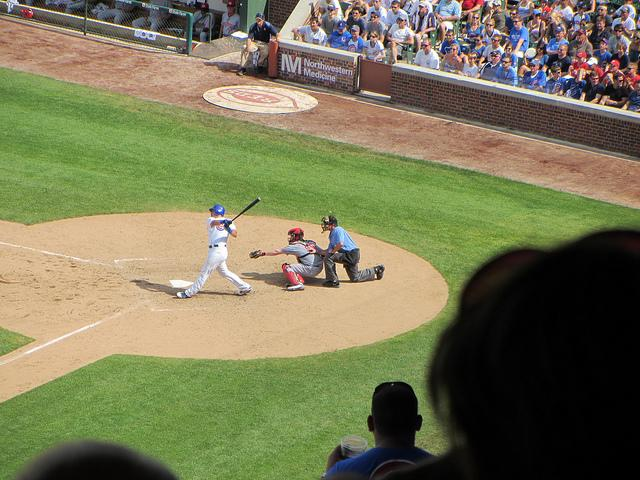What does Northwestern Medicine provide in this game? sponsorship 